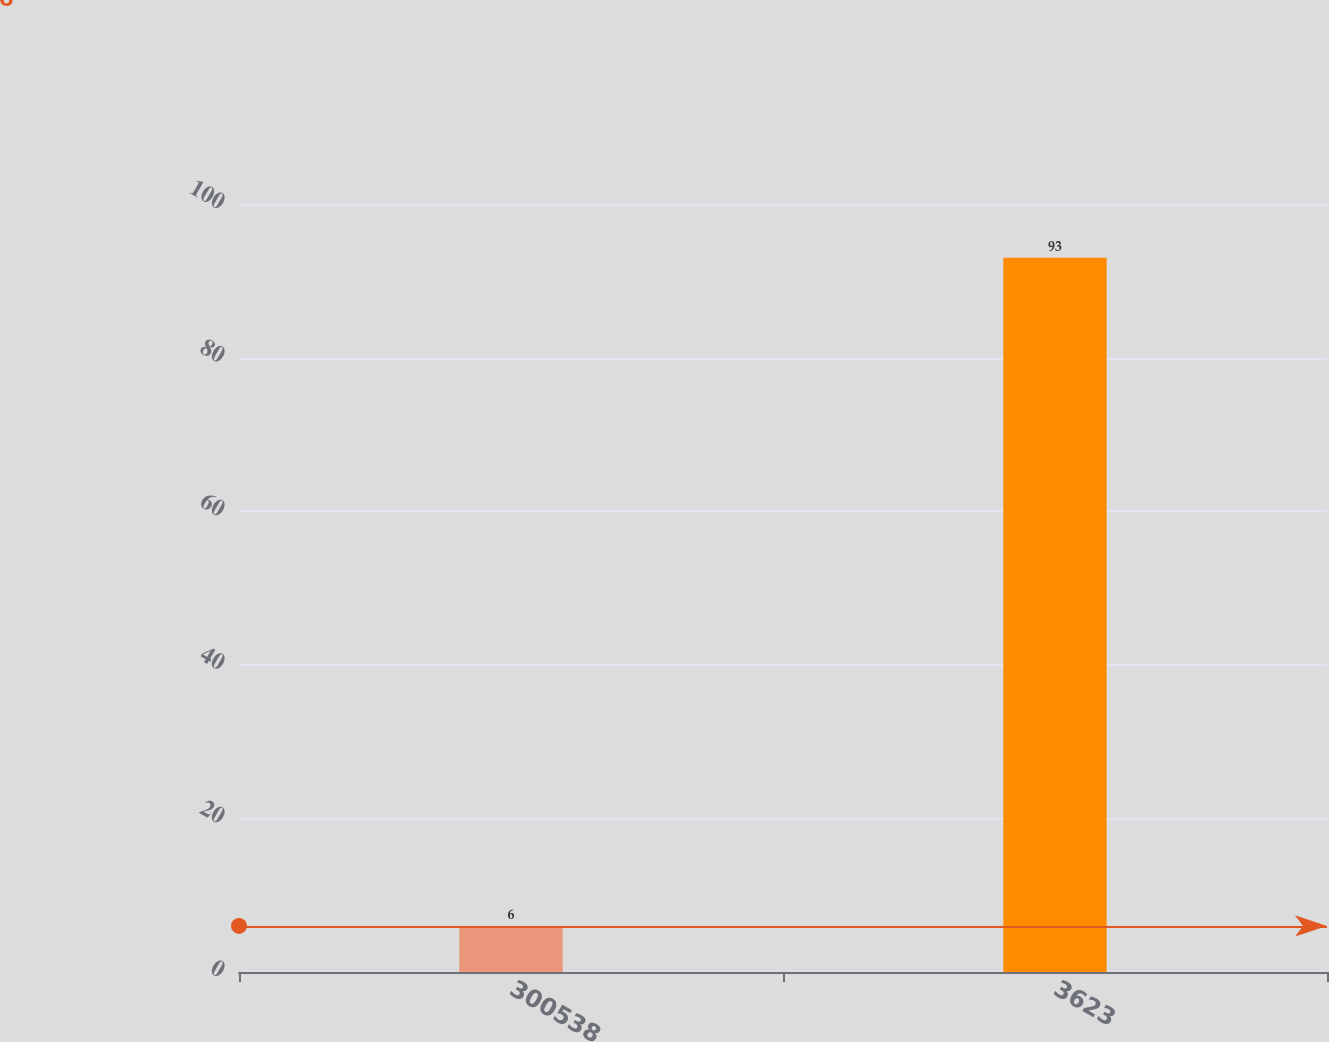<chart> <loc_0><loc_0><loc_500><loc_500><bar_chart><fcel>300538<fcel>3623<nl><fcel>6<fcel>93<nl></chart> 